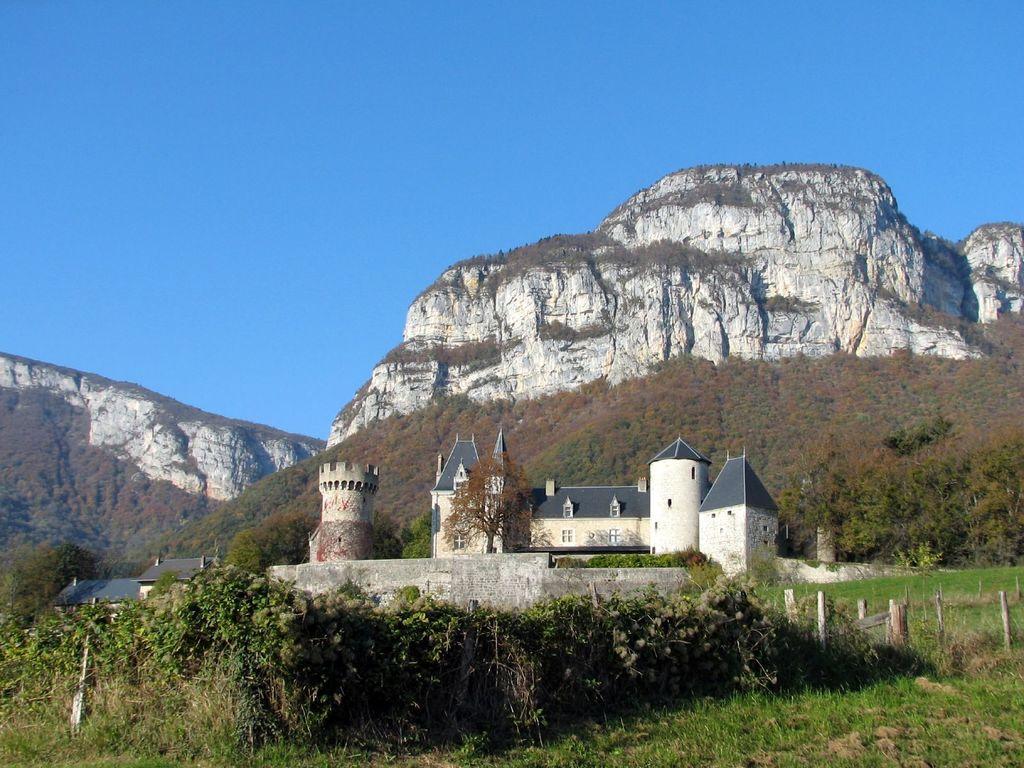In one or two sentences, can you explain what this image depicts? In the foreground of the picture there are trees, plants, fencing, building and castle. In the middle of the picture we can see mountains and trees. At the top it is sky. 